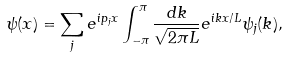Convert formula to latex. <formula><loc_0><loc_0><loc_500><loc_500>\psi ( x ) = \sum _ { j } e ^ { i p _ { j } x } \int _ { - \pi } ^ { \pi } \frac { d k } { \sqrt { 2 \pi L } } e ^ { i k x / L } \psi _ { j } ( k ) ,</formula> 